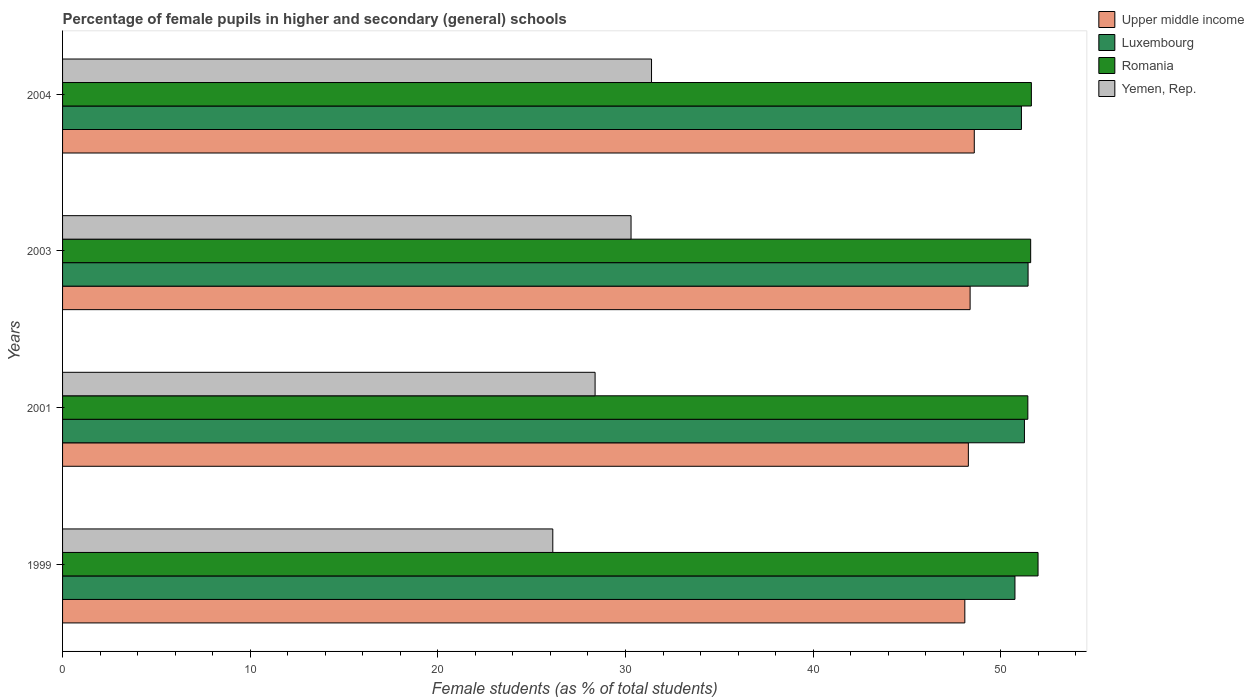How many groups of bars are there?
Your answer should be very brief. 4. Are the number of bars per tick equal to the number of legend labels?
Your answer should be compact. Yes. How many bars are there on the 3rd tick from the top?
Make the answer very short. 4. What is the percentage of female pupils in higher and secondary schools in Upper middle income in 2001?
Give a very brief answer. 48.27. Across all years, what is the maximum percentage of female pupils in higher and secondary schools in Romania?
Give a very brief answer. 51.99. Across all years, what is the minimum percentage of female pupils in higher and secondary schools in Romania?
Make the answer very short. 51.44. What is the total percentage of female pupils in higher and secondary schools in Luxembourg in the graph?
Give a very brief answer. 204.57. What is the difference between the percentage of female pupils in higher and secondary schools in Yemen, Rep. in 1999 and that in 2004?
Offer a terse response. -5.26. What is the difference between the percentage of female pupils in higher and secondary schools in Upper middle income in 2004 and the percentage of female pupils in higher and secondary schools in Romania in 2001?
Provide a succinct answer. -2.85. What is the average percentage of female pupils in higher and secondary schools in Upper middle income per year?
Provide a succinct answer. 48.33. In the year 2004, what is the difference between the percentage of female pupils in higher and secondary schools in Yemen, Rep. and percentage of female pupils in higher and secondary schools in Romania?
Provide a short and direct response. -20.24. What is the ratio of the percentage of female pupils in higher and secondary schools in Upper middle income in 2003 to that in 2004?
Offer a very short reply. 1. Is the percentage of female pupils in higher and secondary schools in Yemen, Rep. in 1999 less than that in 2001?
Your response must be concise. Yes. Is the difference between the percentage of female pupils in higher and secondary schools in Yemen, Rep. in 2001 and 2004 greater than the difference between the percentage of female pupils in higher and secondary schools in Romania in 2001 and 2004?
Give a very brief answer. No. What is the difference between the highest and the second highest percentage of female pupils in higher and secondary schools in Luxembourg?
Provide a succinct answer. 0.19. What is the difference between the highest and the lowest percentage of female pupils in higher and secondary schools in Romania?
Provide a short and direct response. 0.54. What does the 2nd bar from the top in 2003 represents?
Make the answer very short. Romania. What does the 2nd bar from the bottom in 1999 represents?
Your response must be concise. Luxembourg. Is it the case that in every year, the sum of the percentage of female pupils in higher and secondary schools in Upper middle income and percentage of female pupils in higher and secondary schools in Romania is greater than the percentage of female pupils in higher and secondary schools in Luxembourg?
Provide a succinct answer. Yes. How many years are there in the graph?
Your response must be concise. 4. What is the difference between two consecutive major ticks on the X-axis?
Provide a succinct answer. 10. Does the graph contain grids?
Provide a short and direct response. No. What is the title of the graph?
Ensure brevity in your answer.  Percentage of female pupils in higher and secondary (general) schools. What is the label or title of the X-axis?
Keep it short and to the point. Female students (as % of total students). What is the Female students (as % of total students) of Upper middle income in 1999?
Your answer should be very brief. 48.08. What is the Female students (as % of total students) of Luxembourg in 1999?
Your answer should be compact. 50.76. What is the Female students (as % of total students) in Romania in 1999?
Your response must be concise. 51.99. What is the Female students (as % of total students) in Yemen, Rep. in 1999?
Your response must be concise. 26.13. What is the Female students (as % of total students) in Upper middle income in 2001?
Provide a short and direct response. 48.27. What is the Female students (as % of total students) of Luxembourg in 2001?
Your answer should be very brief. 51.26. What is the Female students (as % of total students) of Romania in 2001?
Offer a very short reply. 51.44. What is the Female students (as % of total students) in Yemen, Rep. in 2001?
Your answer should be compact. 28.38. What is the Female students (as % of total students) of Upper middle income in 2003?
Offer a very short reply. 48.37. What is the Female students (as % of total students) in Luxembourg in 2003?
Your answer should be compact. 51.46. What is the Female students (as % of total students) of Romania in 2003?
Provide a short and direct response. 51.59. What is the Female students (as % of total students) in Yemen, Rep. in 2003?
Offer a very short reply. 30.3. What is the Female students (as % of total students) in Upper middle income in 2004?
Provide a short and direct response. 48.59. What is the Female students (as % of total students) of Luxembourg in 2004?
Ensure brevity in your answer.  51.1. What is the Female students (as % of total students) of Romania in 2004?
Offer a very short reply. 51.63. What is the Female students (as % of total students) in Yemen, Rep. in 2004?
Give a very brief answer. 31.39. Across all years, what is the maximum Female students (as % of total students) of Upper middle income?
Provide a succinct answer. 48.59. Across all years, what is the maximum Female students (as % of total students) in Luxembourg?
Provide a succinct answer. 51.46. Across all years, what is the maximum Female students (as % of total students) in Romania?
Your answer should be compact. 51.99. Across all years, what is the maximum Female students (as % of total students) in Yemen, Rep.?
Offer a terse response. 31.39. Across all years, what is the minimum Female students (as % of total students) in Upper middle income?
Offer a very short reply. 48.08. Across all years, what is the minimum Female students (as % of total students) in Luxembourg?
Your answer should be very brief. 50.76. Across all years, what is the minimum Female students (as % of total students) in Romania?
Ensure brevity in your answer.  51.44. Across all years, what is the minimum Female students (as % of total students) of Yemen, Rep.?
Offer a very short reply. 26.13. What is the total Female students (as % of total students) in Upper middle income in the graph?
Ensure brevity in your answer.  193.31. What is the total Female students (as % of total students) in Luxembourg in the graph?
Your response must be concise. 204.57. What is the total Female students (as % of total students) in Romania in the graph?
Ensure brevity in your answer.  206.65. What is the total Female students (as % of total students) in Yemen, Rep. in the graph?
Give a very brief answer. 116.19. What is the difference between the Female students (as % of total students) of Upper middle income in 1999 and that in 2001?
Ensure brevity in your answer.  -0.19. What is the difference between the Female students (as % of total students) of Luxembourg in 1999 and that in 2001?
Keep it short and to the point. -0.51. What is the difference between the Female students (as % of total students) in Romania in 1999 and that in 2001?
Ensure brevity in your answer.  0.54. What is the difference between the Female students (as % of total students) of Yemen, Rep. in 1999 and that in 2001?
Provide a short and direct response. -2.25. What is the difference between the Female students (as % of total students) of Upper middle income in 1999 and that in 2003?
Give a very brief answer. -0.28. What is the difference between the Female students (as % of total students) in Luxembourg in 1999 and that in 2003?
Keep it short and to the point. -0.7. What is the difference between the Female students (as % of total students) in Romania in 1999 and that in 2003?
Make the answer very short. 0.39. What is the difference between the Female students (as % of total students) in Yemen, Rep. in 1999 and that in 2003?
Provide a succinct answer. -4.17. What is the difference between the Female students (as % of total students) of Upper middle income in 1999 and that in 2004?
Your answer should be very brief. -0.5. What is the difference between the Female students (as % of total students) in Luxembourg in 1999 and that in 2004?
Keep it short and to the point. -0.35. What is the difference between the Female students (as % of total students) in Romania in 1999 and that in 2004?
Your answer should be very brief. 0.36. What is the difference between the Female students (as % of total students) in Yemen, Rep. in 1999 and that in 2004?
Your answer should be very brief. -5.26. What is the difference between the Female students (as % of total students) in Upper middle income in 2001 and that in 2003?
Ensure brevity in your answer.  -0.09. What is the difference between the Female students (as % of total students) of Luxembourg in 2001 and that in 2003?
Keep it short and to the point. -0.19. What is the difference between the Female students (as % of total students) of Romania in 2001 and that in 2003?
Make the answer very short. -0.15. What is the difference between the Female students (as % of total students) in Yemen, Rep. in 2001 and that in 2003?
Make the answer very short. -1.92. What is the difference between the Female students (as % of total students) of Upper middle income in 2001 and that in 2004?
Ensure brevity in your answer.  -0.32. What is the difference between the Female students (as % of total students) of Luxembourg in 2001 and that in 2004?
Provide a succinct answer. 0.16. What is the difference between the Female students (as % of total students) in Romania in 2001 and that in 2004?
Your answer should be compact. -0.19. What is the difference between the Female students (as % of total students) of Yemen, Rep. in 2001 and that in 2004?
Keep it short and to the point. -3.01. What is the difference between the Female students (as % of total students) in Upper middle income in 2003 and that in 2004?
Your response must be concise. -0.22. What is the difference between the Female students (as % of total students) in Luxembourg in 2003 and that in 2004?
Offer a terse response. 0.35. What is the difference between the Female students (as % of total students) of Romania in 2003 and that in 2004?
Your answer should be compact. -0.04. What is the difference between the Female students (as % of total students) in Yemen, Rep. in 2003 and that in 2004?
Your answer should be very brief. -1.09. What is the difference between the Female students (as % of total students) of Upper middle income in 1999 and the Female students (as % of total students) of Luxembourg in 2001?
Ensure brevity in your answer.  -3.18. What is the difference between the Female students (as % of total students) in Upper middle income in 1999 and the Female students (as % of total students) in Romania in 2001?
Ensure brevity in your answer.  -3.36. What is the difference between the Female students (as % of total students) of Upper middle income in 1999 and the Female students (as % of total students) of Yemen, Rep. in 2001?
Your answer should be very brief. 19.7. What is the difference between the Female students (as % of total students) in Luxembourg in 1999 and the Female students (as % of total students) in Romania in 2001?
Make the answer very short. -0.69. What is the difference between the Female students (as % of total students) in Luxembourg in 1999 and the Female students (as % of total students) in Yemen, Rep. in 2001?
Provide a succinct answer. 22.38. What is the difference between the Female students (as % of total students) in Romania in 1999 and the Female students (as % of total students) in Yemen, Rep. in 2001?
Make the answer very short. 23.61. What is the difference between the Female students (as % of total students) of Upper middle income in 1999 and the Female students (as % of total students) of Luxembourg in 2003?
Ensure brevity in your answer.  -3.37. What is the difference between the Female students (as % of total students) of Upper middle income in 1999 and the Female students (as % of total students) of Romania in 2003?
Keep it short and to the point. -3.51. What is the difference between the Female students (as % of total students) of Upper middle income in 1999 and the Female students (as % of total students) of Yemen, Rep. in 2003?
Make the answer very short. 17.79. What is the difference between the Female students (as % of total students) in Luxembourg in 1999 and the Female students (as % of total students) in Romania in 2003?
Keep it short and to the point. -0.84. What is the difference between the Female students (as % of total students) of Luxembourg in 1999 and the Female students (as % of total students) of Yemen, Rep. in 2003?
Make the answer very short. 20.46. What is the difference between the Female students (as % of total students) of Romania in 1999 and the Female students (as % of total students) of Yemen, Rep. in 2003?
Your answer should be very brief. 21.69. What is the difference between the Female students (as % of total students) in Upper middle income in 1999 and the Female students (as % of total students) in Luxembourg in 2004?
Make the answer very short. -3.02. What is the difference between the Female students (as % of total students) of Upper middle income in 1999 and the Female students (as % of total students) of Romania in 2004?
Provide a short and direct response. -3.55. What is the difference between the Female students (as % of total students) of Upper middle income in 1999 and the Female students (as % of total students) of Yemen, Rep. in 2004?
Your answer should be compact. 16.7. What is the difference between the Female students (as % of total students) in Luxembourg in 1999 and the Female students (as % of total students) in Romania in 2004?
Make the answer very short. -0.87. What is the difference between the Female students (as % of total students) in Luxembourg in 1999 and the Female students (as % of total students) in Yemen, Rep. in 2004?
Provide a succinct answer. 19.37. What is the difference between the Female students (as % of total students) of Romania in 1999 and the Female students (as % of total students) of Yemen, Rep. in 2004?
Make the answer very short. 20.6. What is the difference between the Female students (as % of total students) of Upper middle income in 2001 and the Female students (as % of total students) of Luxembourg in 2003?
Offer a terse response. -3.18. What is the difference between the Female students (as % of total students) in Upper middle income in 2001 and the Female students (as % of total students) in Romania in 2003?
Give a very brief answer. -3.32. What is the difference between the Female students (as % of total students) in Upper middle income in 2001 and the Female students (as % of total students) in Yemen, Rep. in 2003?
Offer a terse response. 17.98. What is the difference between the Female students (as % of total students) of Luxembourg in 2001 and the Female students (as % of total students) of Romania in 2003?
Offer a terse response. -0.33. What is the difference between the Female students (as % of total students) of Luxembourg in 2001 and the Female students (as % of total students) of Yemen, Rep. in 2003?
Your answer should be very brief. 20.97. What is the difference between the Female students (as % of total students) of Romania in 2001 and the Female students (as % of total students) of Yemen, Rep. in 2003?
Make the answer very short. 21.15. What is the difference between the Female students (as % of total students) in Upper middle income in 2001 and the Female students (as % of total students) in Luxembourg in 2004?
Provide a short and direct response. -2.83. What is the difference between the Female students (as % of total students) of Upper middle income in 2001 and the Female students (as % of total students) of Romania in 2004?
Make the answer very short. -3.36. What is the difference between the Female students (as % of total students) of Upper middle income in 2001 and the Female students (as % of total students) of Yemen, Rep. in 2004?
Your response must be concise. 16.88. What is the difference between the Female students (as % of total students) in Luxembourg in 2001 and the Female students (as % of total students) in Romania in 2004?
Offer a very short reply. -0.37. What is the difference between the Female students (as % of total students) of Luxembourg in 2001 and the Female students (as % of total students) of Yemen, Rep. in 2004?
Your answer should be very brief. 19.87. What is the difference between the Female students (as % of total students) of Romania in 2001 and the Female students (as % of total students) of Yemen, Rep. in 2004?
Keep it short and to the point. 20.05. What is the difference between the Female students (as % of total students) in Upper middle income in 2003 and the Female students (as % of total students) in Luxembourg in 2004?
Give a very brief answer. -2.74. What is the difference between the Female students (as % of total students) in Upper middle income in 2003 and the Female students (as % of total students) in Romania in 2004?
Offer a very short reply. -3.26. What is the difference between the Female students (as % of total students) of Upper middle income in 2003 and the Female students (as % of total students) of Yemen, Rep. in 2004?
Your answer should be compact. 16.98. What is the difference between the Female students (as % of total students) in Luxembourg in 2003 and the Female students (as % of total students) in Romania in 2004?
Make the answer very short. -0.18. What is the difference between the Female students (as % of total students) of Luxembourg in 2003 and the Female students (as % of total students) of Yemen, Rep. in 2004?
Your response must be concise. 20.07. What is the difference between the Female students (as % of total students) of Romania in 2003 and the Female students (as % of total students) of Yemen, Rep. in 2004?
Give a very brief answer. 20.21. What is the average Female students (as % of total students) of Upper middle income per year?
Provide a short and direct response. 48.33. What is the average Female students (as % of total students) of Luxembourg per year?
Provide a succinct answer. 51.14. What is the average Female students (as % of total students) of Romania per year?
Offer a terse response. 51.66. What is the average Female students (as % of total students) of Yemen, Rep. per year?
Provide a short and direct response. 29.05. In the year 1999, what is the difference between the Female students (as % of total students) in Upper middle income and Female students (as % of total students) in Luxembourg?
Your response must be concise. -2.67. In the year 1999, what is the difference between the Female students (as % of total students) in Upper middle income and Female students (as % of total students) in Romania?
Ensure brevity in your answer.  -3.9. In the year 1999, what is the difference between the Female students (as % of total students) in Upper middle income and Female students (as % of total students) in Yemen, Rep.?
Ensure brevity in your answer.  21.96. In the year 1999, what is the difference between the Female students (as % of total students) in Luxembourg and Female students (as % of total students) in Romania?
Your answer should be very brief. -1.23. In the year 1999, what is the difference between the Female students (as % of total students) in Luxembourg and Female students (as % of total students) in Yemen, Rep.?
Provide a succinct answer. 24.63. In the year 1999, what is the difference between the Female students (as % of total students) of Romania and Female students (as % of total students) of Yemen, Rep.?
Your response must be concise. 25.86. In the year 2001, what is the difference between the Female students (as % of total students) of Upper middle income and Female students (as % of total students) of Luxembourg?
Your answer should be compact. -2.99. In the year 2001, what is the difference between the Female students (as % of total students) in Upper middle income and Female students (as % of total students) in Romania?
Ensure brevity in your answer.  -3.17. In the year 2001, what is the difference between the Female students (as % of total students) of Upper middle income and Female students (as % of total students) of Yemen, Rep.?
Make the answer very short. 19.89. In the year 2001, what is the difference between the Female students (as % of total students) in Luxembourg and Female students (as % of total students) in Romania?
Make the answer very short. -0.18. In the year 2001, what is the difference between the Female students (as % of total students) in Luxembourg and Female students (as % of total students) in Yemen, Rep.?
Provide a short and direct response. 22.88. In the year 2001, what is the difference between the Female students (as % of total students) of Romania and Female students (as % of total students) of Yemen, Rep.?
Provide a short and direct response. 23.06. In the year 2003, what is the difference between the Female students (as % of total students) of Upper middle income and Female students (as % of total students) of Luxembourg?
Offer a very short reply. -3.09. In the year 2003, what is the difference between the Female students (as % of total students) of Upper middle income and Female students (as % of total students) of Romania?
Keep it short and to the point. -3.23. In the year 2003, what is the difference between the Female students (as % of total students) in Upper middle income and Female students (as % of total students) in Yemen, Rep.?
Provide a short and direct response. 18.07. In the year 2003, what is the difference between the Female students (as % of total students) in Luxembourg and Female students (as % of total students) in Romania?
Offer a very short reply. -0.14. In the year 2003, what is the difference between the Female students (as % of total students) in Luxembourg and Female students (as % of total students) in Yemen, Rep.?
Keep it short and to the point. 21.16. In the year 2003, what is the difference between the Female students (as % of total students) of Romania and Female students (as % of total students) of Yemen, Rep.?
Give a very brief answer. 21.3. In the year 2004, what is the difference between the Female students (as % of total students) in Upper middle income and Female students (as % of total students) in Luxembourg?
Provide a succinct answer. -2.51. In the year 2004, what is the difference between the Female students (as % of total students) of Upper middle income and Female students (as % of total students) of Romania?
Your response must be concise. -3.04. In the year 2004, what is the difference between the Female students (as % of total students) in Upper middle income and Female students (as % of total students) in Yemen, Rep.?
Give a very brief answer. 17.2. In the year 2004, what is the difference between the Female students (as % of total students) of Luxembourg and Female students (as % of total students) of Romania?
Ensure brevity in your answer.  -0.53. In the year 2004, what is the difference between the Female students (as % of total students) in Luxembourg and Female students (as % of total students) in Yemen, Rep.?
Give a very brief answer. 19.71. In the year 2004, what is the difference between the Female students (as % of total students) in Romania and Female students (as % of total students) in Yemen, Rep.?
Your answer should be very brief. 20.24. What is the ratio of the Female students (as % of total students) of Luxembourg in 1999 to that in 2001?
Your answer should be very brief. 0.99. What is the ratio of the Female students (as % of total students) in Romania in 1999 to that in 2001?
Your answer should be very brief. 1.01. What is the ratio of the Female students (as % of total students) of Yemen, Rep. in 1999 to that in 2001?
Ensure brevity in your answer.  0.92. What is the ratio of the Female students (as % of total students) in Upper middle income in 1999 to that in 2003?
Provide a short and direct response. 0.99. What is the ratio of the Female students (as % of total students) in Luxembourg in 1999 to that in 2003?
Keep it short and to the point. 0.99. What is the ratio of the Female students (as % of total students) of Romania in 1999 to that in 2003?
Give a very brief answer. 1.01. What is the ratio of the Female students (as % of total students) in Yemen, Rep. in 1999 to that in 2003?
Ensure brevity in your answer.  0.86. What is the ratio of the Female students (as % of total students) of Upper middle income in 1999 to that in 2004?
Provide a succinct answer. 0.99. What is the ratio of the Female students (as % of total students) of Luxembourg in 1999 to that in 2004?
Offer a terse response. 0.99. What is the ratio of the Female students (as % of total students) in Yemen, Rep. in 1999 to that in 2004?
Provide a succinct answer. 0.83. What is the ratio of the Female students (as % of total students) in Luxembourg in 2001 to that in 2003?
Provide a short and direct response. 1. What is the ratio of the Female students (as % of total students) of Yemen, Rep. in 2001 to that in 2003?
Keep it short and to the point. 0.94. What is the ratio of the Female students (as % of total students) of Luxembourg in 2001 to that in 2004?
Ensure brevity in your answer.  1. What is the ratio of the Female students (as % of total students) in Romania in 2001 to that in 2004?
Keep it short and to the point. 1. What is the ratio of the Female students (as % of total students) in Yemen, Rep. in 2001 to that in 2004?
Provide a succinct answer. 0.9. What is the ratio of the Female students (as % of total students) of Luxembourg in 2003 to that in 2004?
Offer a terse response. 1.01. What is the ratio of the Female students (as % of total students) in Yemen, Rep. in 2003 to that in 2004?
Give a very brief answer. 0.97. What is the difference between the highest and the second highest Female students (as % of total students) in Upper middle income?
Keep it short and to the point. 0.22. What is the difference between the highest and the second highest Female students (as % of total students) in Luxembourg?
Offer a very short reply. 0.19. What is the difference between the highest and the second highest Female students (as % of total students) of Romania?
Keep it short and to the point. 0.36. What is the difference between the highest and the second highest Female students (as % of total students) in Yemen, Rep.?
Offer a very short reply. 1.09. What is the difference between the highest and the lowest Female students (as % of total students) of Upper middle income?
Make the answer very short. 0.5. What is the difference between the highest and the lowest Female students (as % of total students) in Luxembourg?
Your response must be concise. 0.7. What is the difference between the highest and the lowest Female students (as % of total students) of Romania?
Keep it short and to the point. 0.54. What is the difference between the highest and the lowest Female students (as % of total students) in Yemen, Rep.?
Provide a succinct answer. 5.26. 